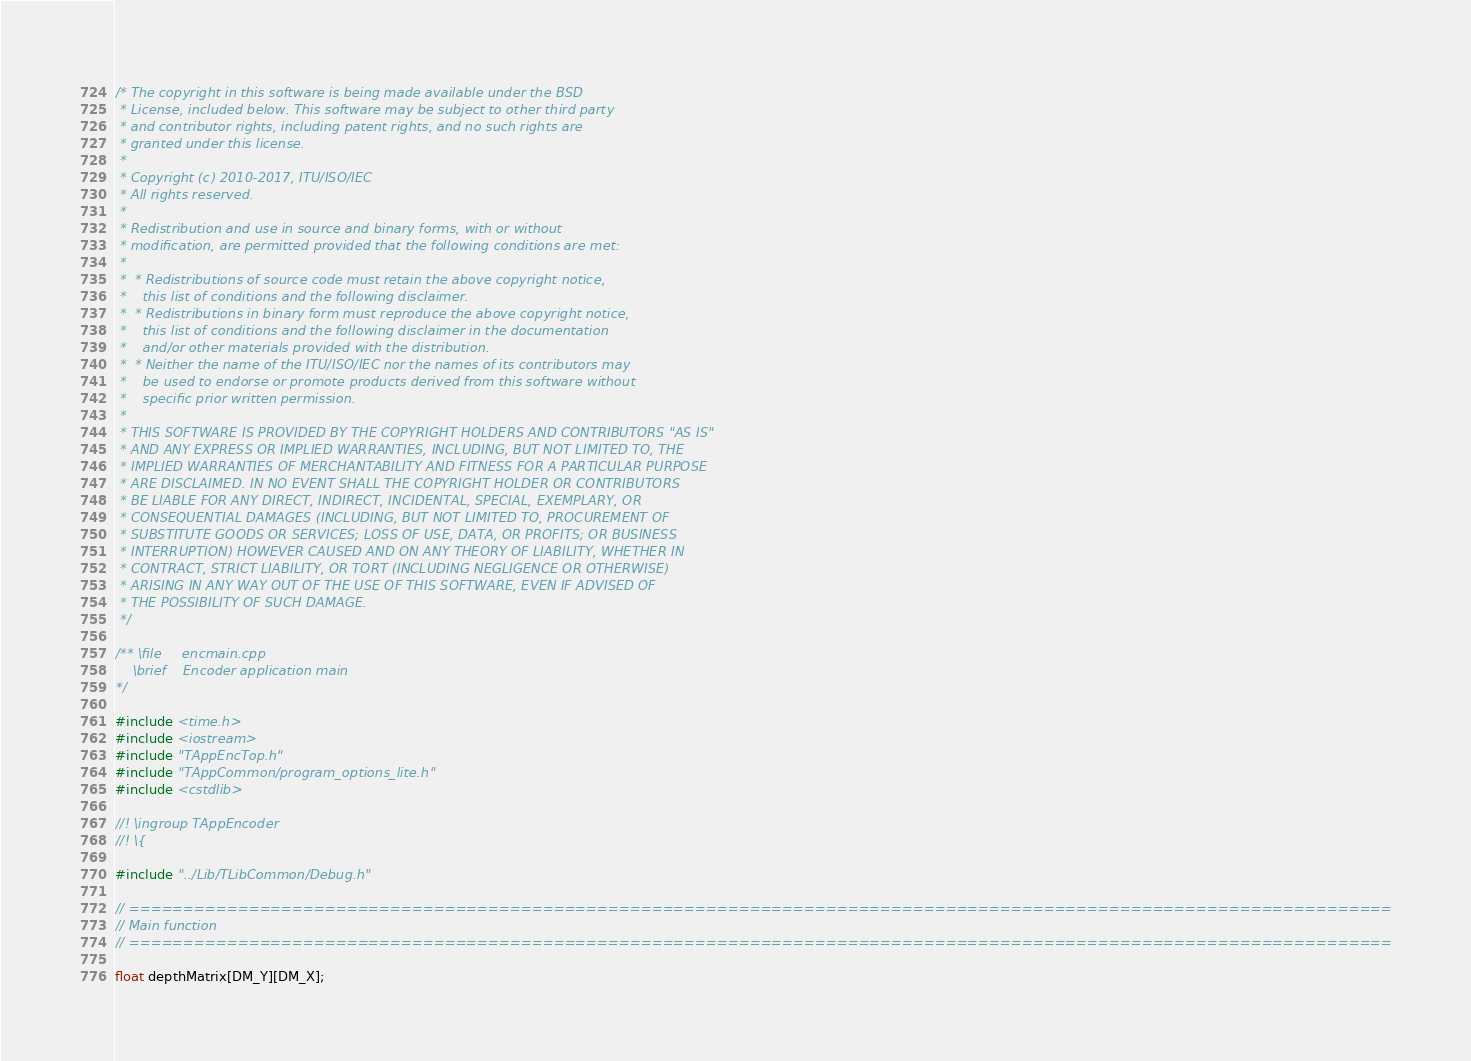<code> <loc_0><loc_0><loc_500><loc_500><_C++_>/* The copyright in this software is being made available under the BSD
 * License, included below. This software may be subject to other third party
 * and contributor rights, including patent rights, and no such rights are
 * granted under this license.
 *
 * Copyright (c) 2010-2017, ITU/ISO/IEC
 * All rights reserved.
 *
 * Redistribution and use in source and binary forms, with or without
 * modification, are permitted provided that the following conditions are met:
 *
 *  * Redistributions of source code must retain the above copyright notice,
 *    this list of conditions and the following disclaimer.
 *  * Redistributions in binary form must reproduce the above copyright notice,
 *    this list of conditions and the following disclaimer in the documentation
 *    and/or other materials provided with the distribution.
 *  * Neither the name of the ITU/ISO/IEC nor the names of its contributors may
 *    be used to endorse or promote products derived from this software without
 *    specific prior written permission.
 *
 * THIS SOFTWARE IS PROVIDED BY THE COPYRIGHT HOLDERS AND CONTRIBUTORS "AS IS"
 * AND ANY EXPRESS OR IMPLIED WARRANTIES, INCLUDING, BUT NOT LIMITED TO, THE
 * IMPLIED WARRANTIES OF MERCHANTABILITY AND FITNESS FOR A PARTICULAR PURPOSE
 * ARE DISCLAIMED. IN NO EVENT SHALL THE COPYRIGHT HOLDER OR CONTRIBUTORS
 * BE LIABLE FOR ANY DIRECT, INDIRECT, INCIDENTAL, SPECIAL, EXEMPLARY, OR
 * CONSEQUENTIAL DAMAGES (INCLUDING, BUT NOT LIMITED TO, PROCUREMENT OF
 * SUBSTITUTE GOODS OR SERVICES; LOSS OF USE, DATA, OR PROFITS; OR BUSINESS
 * INTERRUPTION) HOWEVER CAUSED AND ON ANY THEORY OF LIABILITY, WHETHER IN
 * CONTRACT, STRICT LIABILITY, OR TORT (INCLUDING NEGLIGENCE OR OTHERWISE)
 * ARISING IN ANY WAY OUT OF THE USE OF THIS SOFTWARE, EVEN IF ADVISED OF
 * THE POSSIBILITY OF SUCH DAMAGE.
 */

/** \file     encmain.cpp
    \brief    Encoder application main
*/

#include <time.h>
#include <iostream>
#include "TAppEncTop.h"
#include "TAppCommon/program_options_lite.h"
#include <cstdlib>

//! \ingroup TAppEncoder
//! \{

#include "../Lib/TLibCommon/Debug.h"

// ====================================================================================================================
// Main function
// ====================================================================================================================

float depthMatrix[DM_Y][DM_X];</code> 